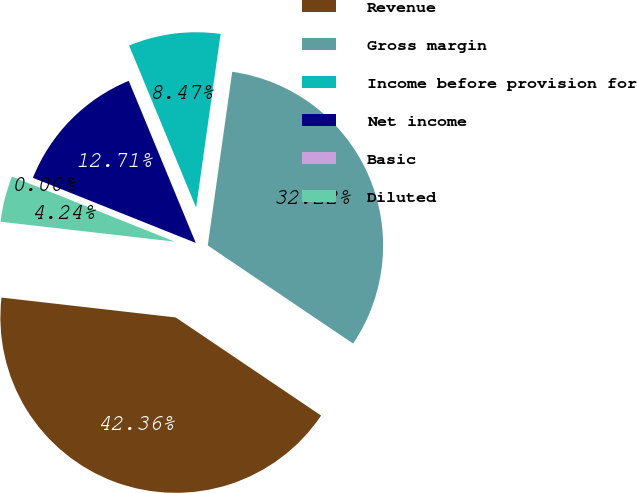<chart> <loc_0><loc_0><loc_500><loc_500><pie_chart><fcel>Revenue<fcel>Gross margin<fcel>Income before provision for<fcel>Net income<fcel>Basic<fcel>Diluted<nl><fcel>42.36%<fcel>32.22%<fcel>8.47%<fcel>12.71%<fcel>0.0%<fcel>4.24%<nl></chart> 